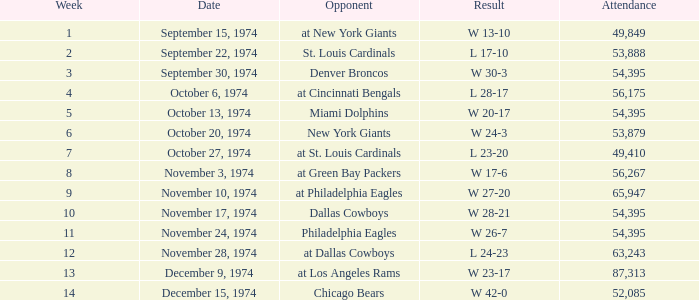What was the outcome of the match with 63,243 attendees following week 9? W 23-17. 